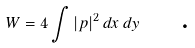<formula> <loc_0><loc_0><loc_500><loc_500>W = 4 \int \left | p \right | ^ { 2 } d x \, d y \text { \quad .}</formula> 